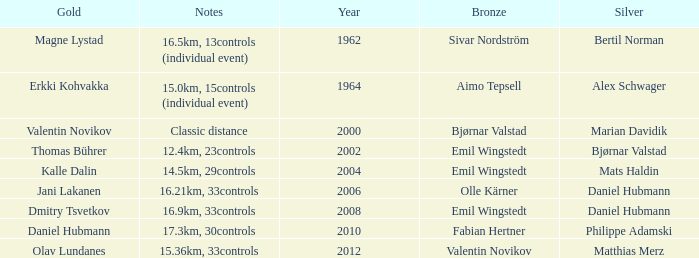WHAT IS THE SILVER WITH A YEAR OF 1962? Bertil Norman. 